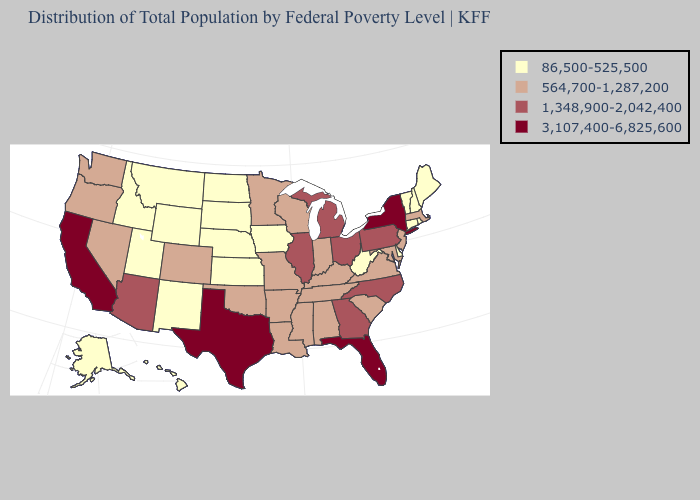Among the states that border Washington , does Idaho have the highest value?
Quick response, please. No. Does Illinois have the highest value in the MidWest?
Answer briefly. Yes. What is the value of Alabama?
Be succinct. 564,700-1,287,200. What is the lowest value in the South?
Short answer required. 86,500-525,500. Does Texas have the highest value in the USA?
Keep it brief. Yes. What is the highest value in states that border Virginia?
Be succinct. 1,348,900-2,042,400. Name the states that have a value in the range 3,107,400-6,825,600?
Keep it brief. California, Florida, New York, Texas. Does Minnesota have a higher value than New Jersey?
Short answer required. No. What is the value of Montana?
Write a very short answer. 86,500-525,500. Name the states that have a value in the range 86,500-525,500?
Write a very short answer. Alaska, Connecticut, Delaware, Hawaii, Idaho, Iowa, Kansas, Maine, Montana, Nebraska, New Hampshire, New Mexico, North Dakota, Rhode Island, South Dakota, Utah, Vermont, West Virginia, Wyoming. What is the value of Minnesota?
Be succinct. 564,700-1,287,200. Among the states that border South Dakota , which have the lowest value?
Quick response, please. Iowa, Montana, Nebraska, North Dakota, Wyoming. What is the highest value in the USA?
Short answer required. 3,107,400-6,825,600. Which states have the highest value in the USA?
Write a very short answer. California, Florida, New York, Texas. What is the highest value in states that border Washington?
Write a very short answer. 564,700-1,287,200. 